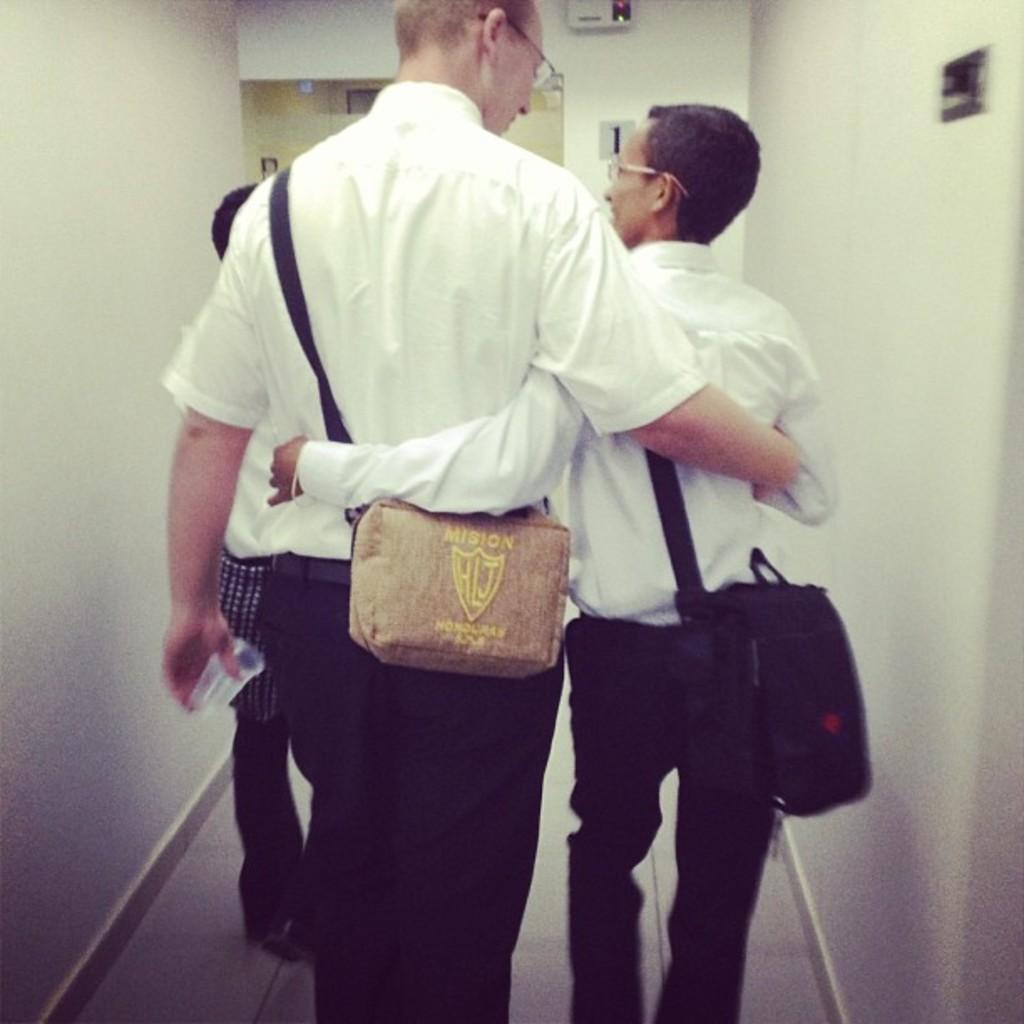How many people are in the image? There are two people in the image. What are the two people doing in the image? The two people are holding each other. What can be seen on the backs of the people in the image? The people are wearing backpacks. What color are the shirts worn by the people in the image? The people are wearing white color shirts. What type of mint is growing in the image? There is no mint present in the image. What is the secretary doing in the image? There is no secretary present in the image. 